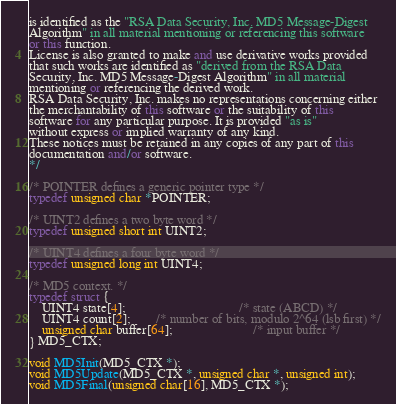Convert code to text. <code><loc_0><loc_0><loc_500><loc_500><_C++_>is identified as the "RSA Data Security, Inc. MD5 Message-Digest
Algorithm" in all material mentioning or referencing this software
or this function.
License is also granted to make and use derivative works provided
that such works are identified as "derived from the RSA Data
Security, Inc. MD5 Message-Digest Algorithm" in all material
mentioning or referencing the derived work.
RSA Data Security, Inc. makes no representations concerning either
the merchantability of this software or the suitability of this
software for any particular purpose. It is provided "as is"
without express or implied warranty of any kind.
These notices must be retained in any copies of any part of this
documentation and/or software.
*/

/* POINTER defines a generic pointer type */
typedef unsigned char *POINTER;

/* UINT2 defines a two byte word */
typedef unsigned short int UINT2;

/* UINT4 defines a four byte word */
typedef unsigned long int UINT4;

/* MD5 context. */
typedef struct {
    UINT4 state[4];                                   /* state (ABCD) */
    UINT4 count[2];        /* number of bits, modulo 2^64 (lsb first) */
    unsigned char buffer[64];                         /* input buffer */
} MD5_CTX;

void MD5Init(MD5_CTX *);
void MD5Update(MD5_CTX *, unsigned char *, unsigned int);
void MD5Final(unsigned char[16], MD5_CTX *);</code> 